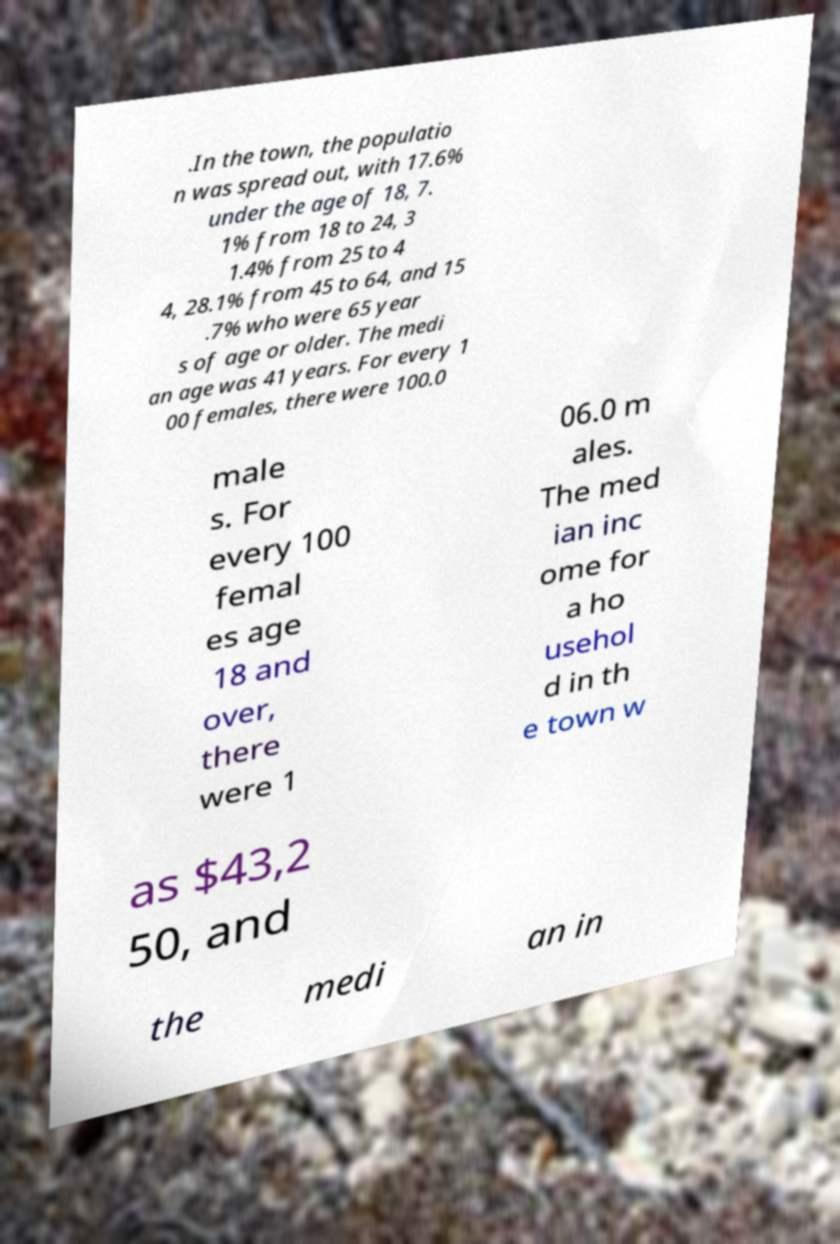Could you assist in decoding the text presented in this image and type it out clearly? .In the town, the populatio n was spread out, with 17.6% under the age of 18, 7. 1% from 18 to 24, 3 1.4% from 25 to 4 4, 28.1% from 45 to 64, and 15 .7% who were 65 year s of age or older. The medi an age was 41 years. For every 1 00 females, there were 100.0 male s. For every 100 femal es age 18 and over, there were 1 06.0 m ales. The med ian inc ome for a ho usehol d in th e town w as $43,2 50, and the medi an in 